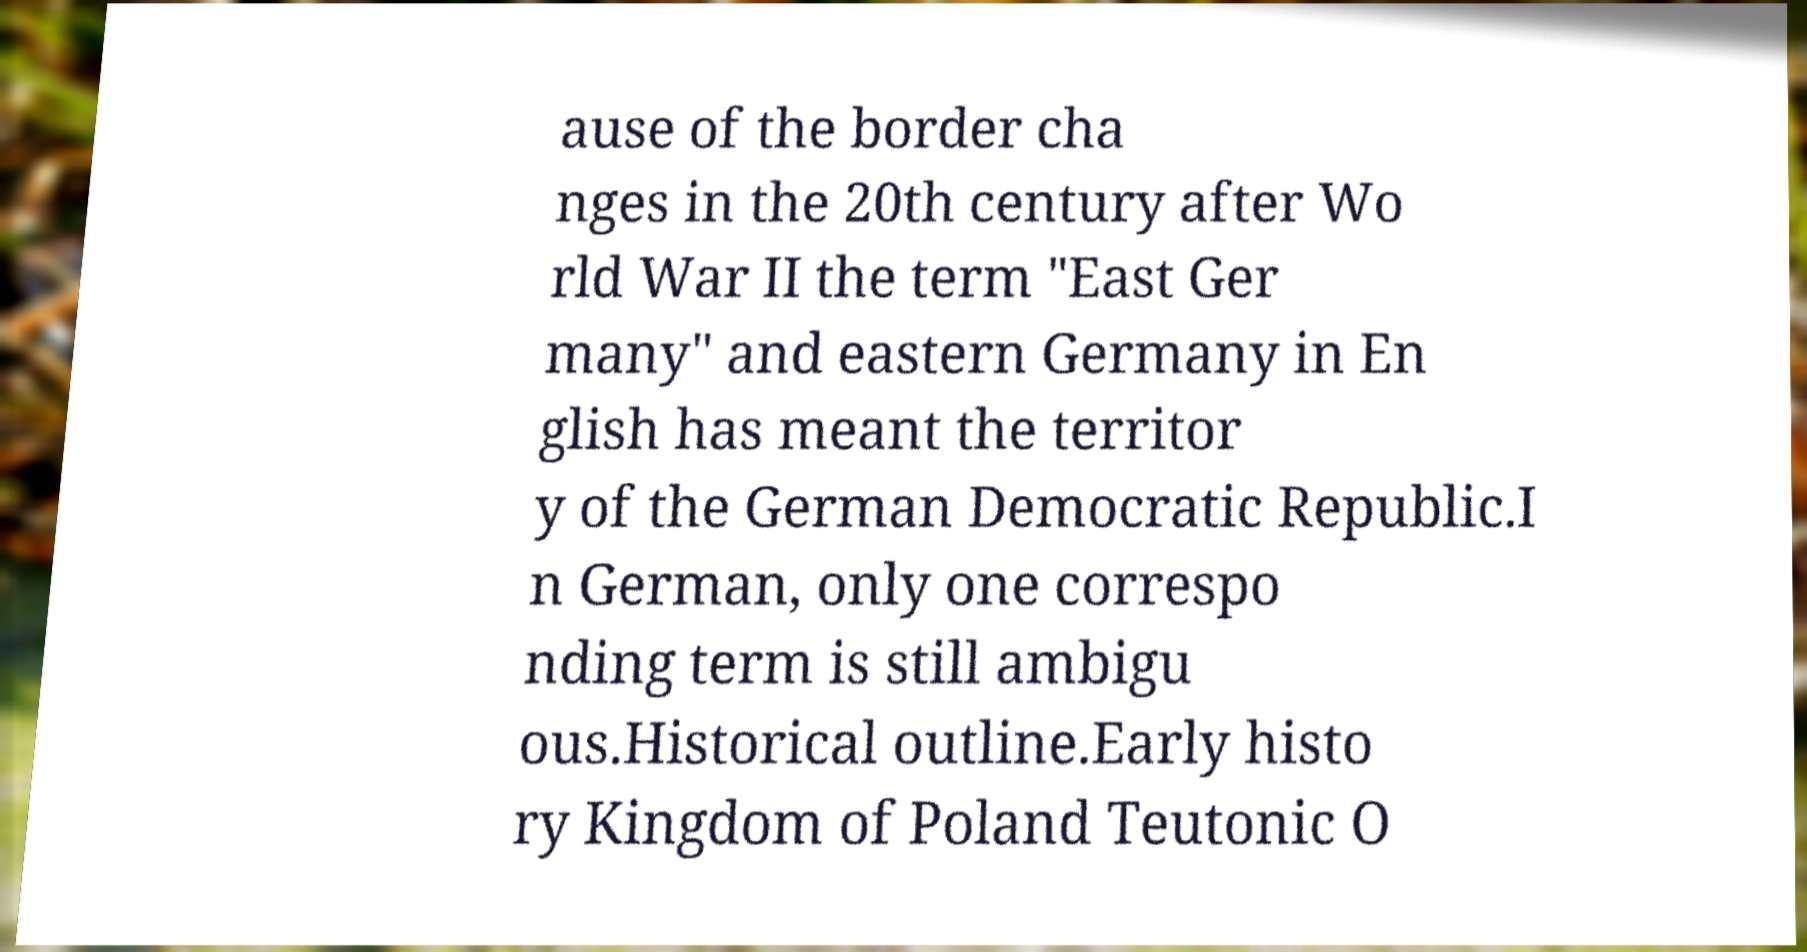Can you read and provide the text displayed in the image?This photo seems to have some interesting text. Can you extract and type it out for me? ause of the border cha nges in the 20th century after Wo rld War II the term "East Ger many" and eastern Germany in En glish has meant the territor y of the German Democratic Republic.I n German, only one correspo nding term is still ambigu ous.Historical outline.Early histo ry Kingdom of Poland Teutonic O 